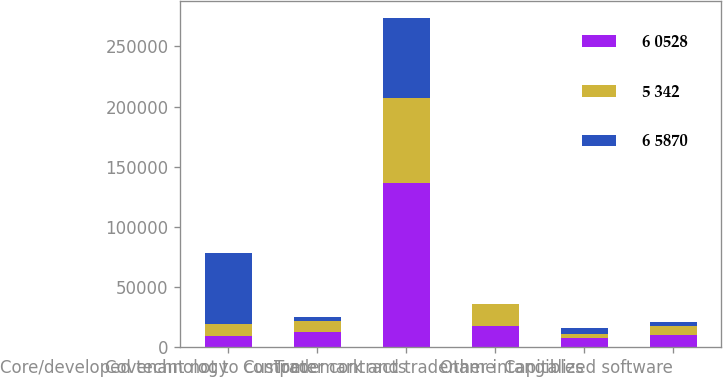Convert chart to OTSL. <chart><loc_0><loc_0><loc_500><loc_500><stacked_bar_chart><ecel><fcel>Core/developed technology<fcel>Covenant not to compete<fcel>Customer contracts<fcel>Trademark and tradename<fcel>Other intangibles<fcel>Capitalized software<nl><fcel>6 0528<fcel>9830.5<fcel>12744<fcel>136940<fcel>18007<fcel>7883<fcel>10587<nl><fcel>5 342<fcel>9830.5<fcel>9074<fcel>70125<fcel>17965<fcel>3051<fcel>7331<nl><fcel>6 5870<fcel>58562<fcel>3670<fcel>66815<fcel>42<fcel>4832<fcel>3256<nl></chart> 